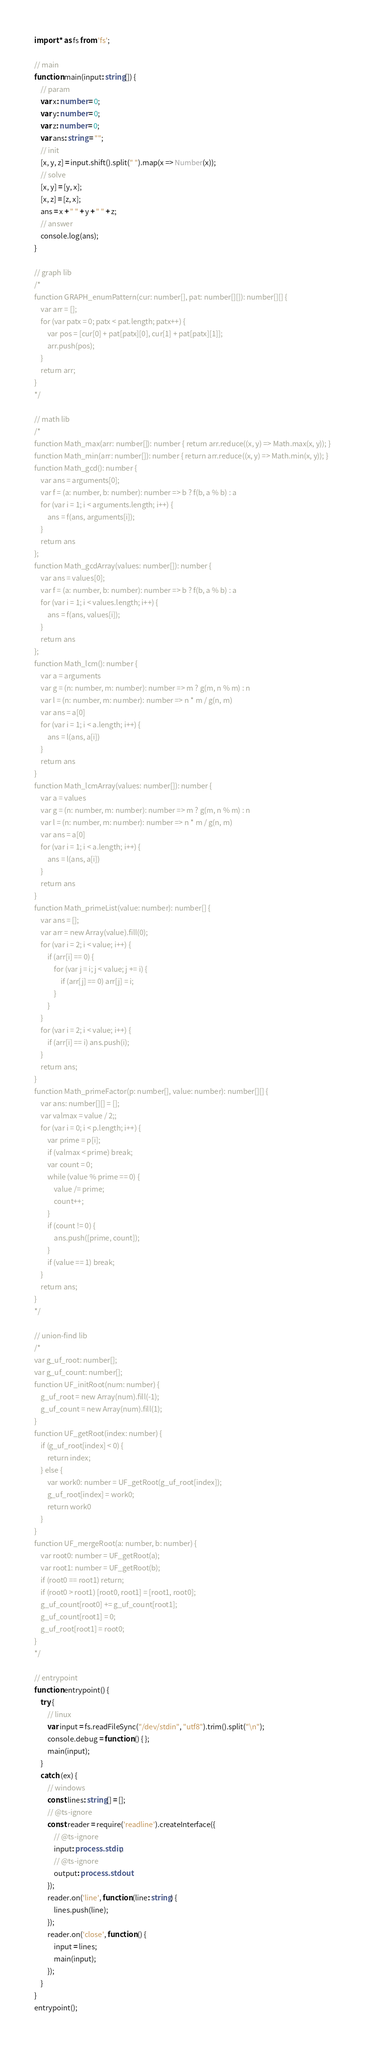Convert code to text. <code><loc_0><loc_0><loc_500><loc_500><_TypeScript_>import * as fs from 'fs';

// main
function main(input: string[]) {
    // param
    var x: number = 0;
    var y: number = 0;
    var z: number = 0;
    var ans: string = "";
    // init
    [x, y, z] = input.shift().split(" ").map(x => Number(x));
    // solve
    [x, y] = [y, x];
    [x, z] = [z, x];
    ans = x + " " + y + " " + z;
    // answer
    console.log(ans);
}

// graph lib
/*
function GRAPH_enumPattern(cur: number[], pat: number[][]): number[][] {
    var arr = [];
    for (var patx = 0; patx < pat.length; patx++) {
        var pos = [cur[0] + pat[patx][0], cur[1] + pat[patx][1]];
        arr.push(pos);
    }
    return arr;
}
*/

// math lib
/*
function Math_max(arr: number[]): number { return arr.reduce((x, y) => Math.max(x, y)); }
function Math_min(arr: number[]): number { return arr.reduce((x, y) => Math.min(x, y)); }
function Math_gcd(): number {
    var ans = arguments[0];
    var f = (a: number, b: number): number => b ? f(b, a % b) : a
    for (var i = 1; i < arguments.length; i++) {
        ans = f(ans, arguments[i]);
    }
    return ans
};
function Math_gcdArray(values: number[]): number {
    var ans = values[0];
    var f = (a: number, b: number): number => b ? f(b, a % b) : a
    for (var i = 1; i < values.length; i++) {
        ans = f(ans, values[i]);
    }
    return ans
};
function Math_lcm(): number {
    var a = arguments
    var g = (n: number, m: number): number => m ? g(m, n % m) : n
    var l = (n: number, m: number): number => n * m / g(n, m)
    var ans = a[0]
    for (var i = 1; i < a.length; i++) {
        ans = l(ans, a[i])
    }
    return ans
}
function Math_lcmArray(values: number[]): number {
    var a = values
    var g = (n: number, m: number): number => m ? g(m, n % m) : n
    var l = (n: number, m: number): number => n * m / g(n, m)
    var ans = a[0]
    for (var i = 1; i < a.length; i++) {
        ans = l(ans, a[i])
    }
    return ans
}
function Math_primeList(value: number): number[] {
    var ans = [];
    var arr = new Array(value).fill(0);
    for (var i = 2; i < value; i++) {
        if (arr[i] == 0) {
            for (var j = i; j < value; j += i) {
                if (arr[j] == 0) arr[j] = i;
            }
        }
    }
    for (var i = 2; i < value; i++) {
        if (arr[i] == i) ans.push(i);
    }
    return ans;
}
function Math_primeFactor(p: number[], value: number): number[][] {
    var ans: number[][] = [];
    var valmax = value / 2;;
    for (var i = 0; i < p.length; i++) {
        var prime = p[i];
        if (valmax < prime) break;
        var count = 0;
        while (value % prime == 0) {
            value /= prime;
            count++;
        }
        if (count != 0) {
            ans.push([prime, count]);
        }
        if (value == 1) break;
    }
    return ans;
}
*/

// union-find lib
/*
var g_uf_root: number[];
var g_uf_count: number[];
function UF_initRoot(num: number) {
    g_uf_root = new Array(num).fill(-1);
    g_uf_count = new Array(num).fill(1);
}
function UF_getRoot(index: number) {
    if (g_uf_root[index] < 0) {
        return index;
    } else {
        var work0: number = UF_getRoot(g_uf_root[index]);
        g_uf_root[index] = work0;
        return work0
    }
}
function UF_mergeRoot(a: number, b: number) {
    var root0: number = UF_getRoot(a);
    var root1: number = UF_getRoot(b);
    if (root0 == root1) return;
    if (root0 > root1) [root0, root1] = [root1, root0];
    g_uf_count[root0] += g_uf_count[root1];
    g_uf_count[root1] = 0;
    g_uf_root[root1] = root0;
}
*/

// entrypoint
function entrypoint() {
    try {
        // linux
        var input = fs.readFileSync("/dev/stdin", "utf8").trim().split("\n");
        console.debug = function () { };
        main(input);
    }
    catch (ex) {
        // windows
        const lines: string[] = [];
        // @ts-ignore
        const reader = require('readline').createInterface({
            // @ts-ignore
            input: process.stdin,
            // @ts-ignore
            output: process.stdout
        });
        reader.on('line', function (line: string) {
            lines.push(line);
        });
        reader.on('close', function () {
            input = lines;
            main(input);
        });
    }
}
entrypoint();
</code> 